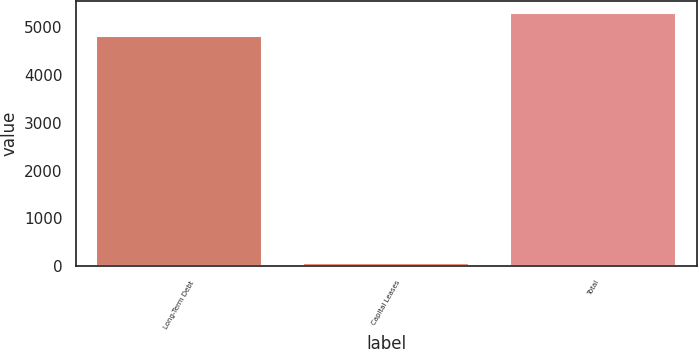Convert chart. <chart><loc_0><loc_0><loc_500><loc_500><bar_chart><fcel>Long-Term Debt<fcel>Capital Leases<fcel>Total<nl><fcel>4796<fcel>73<fcel>5275.6<nl></chart> 